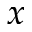Convert formula to latex. <formula><loc_0><loc_0><loc_500><loc_500>x</formula> 